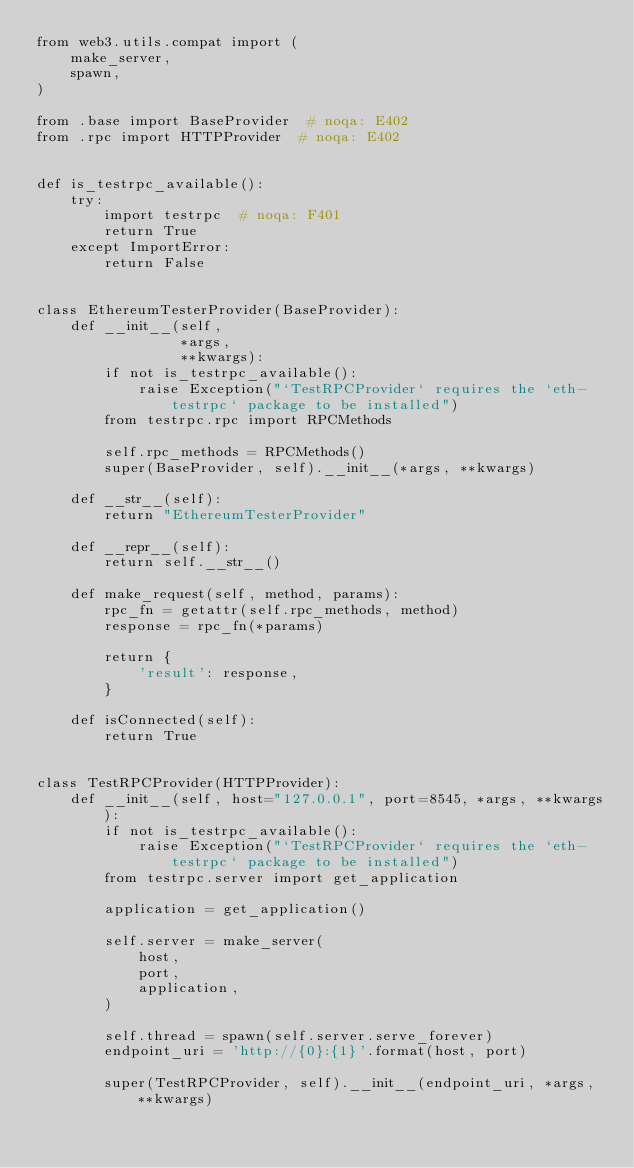Convert code to text. <code><loc_0><loc_0><loc_500><loc_500><_Python_>from web3.utils.compat import (
    make_server,
    spawn,
)

from .base import BaseProvider  # noqa: E402
from .rpc import HTTPProvider  # noqa: E402


def is_testrpc_available():
    try:
        import testrpc  # noqa: F401
        return True
    except ImportError:
        return False


class EthereumTesterProvider(BaseProvider):
    def __init__(self,
                 *args,
                 **kwargs):
        if not is_testrpc_available():
            raise Exception("`TestRPCProvider` requires the `eth-testrpc` package to be installed")
        from testrpc.rpc import RPCMethods

        self.rpc_methods = RPCMethods()
        super(BaseProvider, self).__init__(*args, **kwargs)

    def __str__(self):
        return "EthereumTesterProvider"

    def __repr__(self):
        return self.__str__()

    def make_request(self, method, params):
        rpc_fn = getattr(self.rpc_methods, method)
        response = rpc_fn(*params)

        return {
            'result': response,
        }

    def isConnected(self):
        return True


class TestRPCProvider(HTTPProvider):
    def __init__(self, host="127.0.0.1", port=8545, *args, **kwargs):
        if not is_testrpc_available():
            raise Exception("`TestRPCProvider` requires the `eth-testrpc` package to be installed")
        from testrpc.server import get_application

        application = get_application()

        self.server = make_server(
            host,
            port,
            application,
        )

        self.thread = spawn(self.server.serve_forever)
        endpoint_uri = 'http://{0}:{1}'.format(host, port)

        super(TestRPCProvider, self).__init__(endpoint_uri, *args, **kwargs)
</code> 